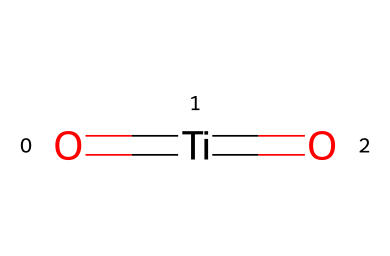What is the central atom in this chemical structure? The chemical structure shows titanium (Ti) as the central atom, flanked by two oxygen atoms each bonded to it. The connections clearly indicate that titanium is the primary element in this molecule.
Answer: titanium How many oxygen atoms are present in this chemical? The SMILES representation indicates that there are two oxygen (O) atoms bonded to one titanium (Ti) atom. Since it expresses O=[Ti]=O, both outer parts denote oxygen atoms.
Answer: two What type of bonding occurs between titanium and oxygen? The representation shows double bonds, as indicated by the '=' between the titanium and the oxygen. Each oxygen is double-bonded to titanium, indicating a strong covalent interaction.
Answer: double What is the oxidation state of titanium in this structure? Titanium is bonded to two oxygen atoms, each in the state of -2 (common for oxygen), which leads to an overall +4 oxidation state for titanium in this context. This is determined by balancing the charges from the oxygen atoms.
Answer: +4 What is the primary use of titanium dioxide in cosmetics? Titanium dioxide is primarily used as a whitening agent. Its high refractive index and ability to scatter light effectively make it ideal for providing opacity and brightness in various cosmetic formulations.
Answer: whitening agent Is titanium dioxide considered safe for cosmetic use? Yes, titanium dioxide is generally regarded as safe (GRAS) for use in cosmetics, as long as it is used appropriately, often classified as non-toxic and stable in formulations. Studies focus on its safety when applied as a pigment.
Answer: safe 